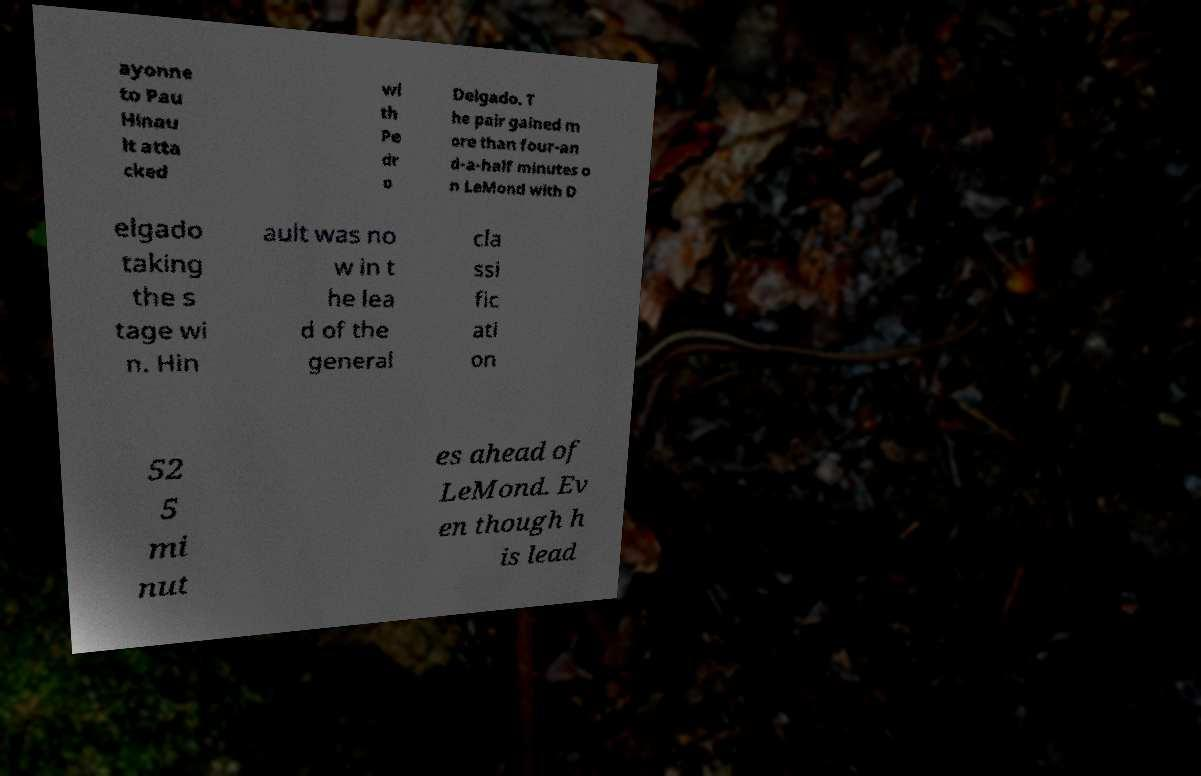Please identify and transcribe the text found in this image. ayonne to Pau Hinau lt atta cked wi th Pe dr o Delgado. T he pair gained m ore than four-an d-a-half minutes o n LeMond with D elgado taking the s tage wi n. Hin ault was no w in t he lea d of the general cla ssi fic ati on 52 5 mi nut es ahead of LeMond. Ev en though h is lead 